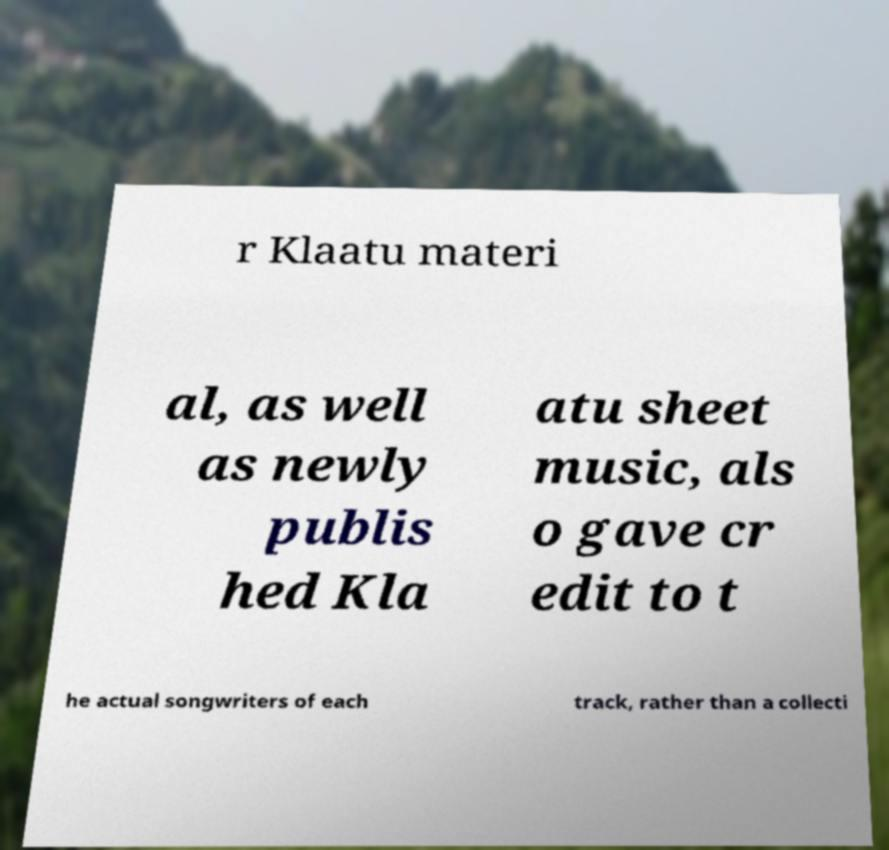Please read and relay the text visible in this image. What does it say? r Klaatu materi al, as well as newly publis hed Kla atu sheet music, als o gave cr edit to t he actual songwriters of each track, rather than a collecti 